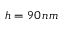<formula> <loc_0><loc_0><loc_500><loc_500>h = 9 0 \, n m</formula> 